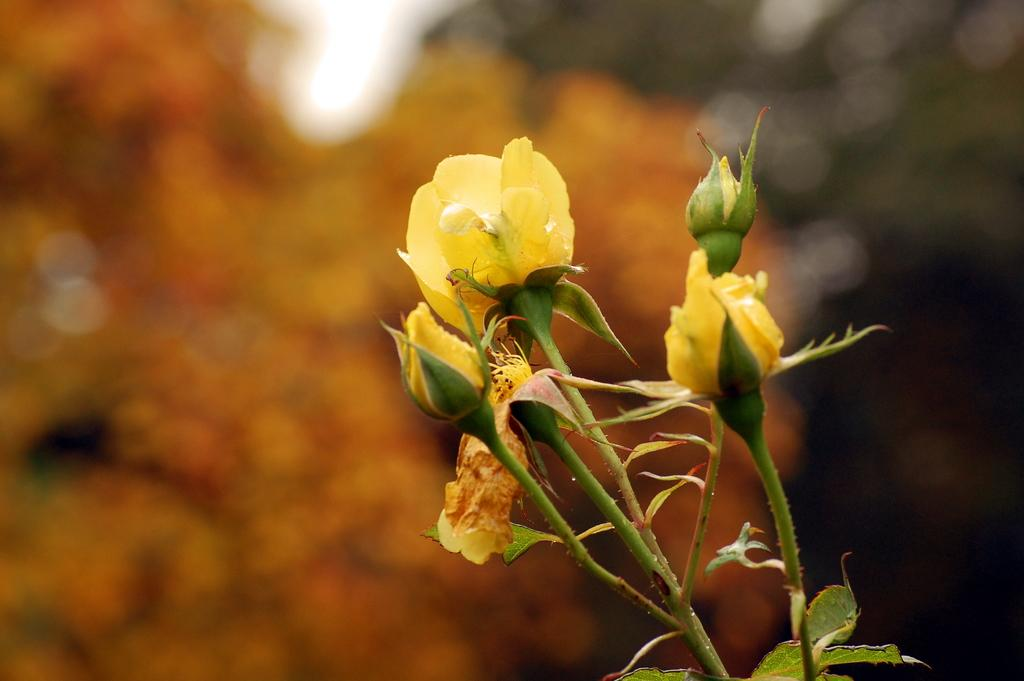What type of flower is in the image? There is a rose flower in the image. What color is the rose flower? The rose flower is yellow. Are there any unopened parts on the rose flower? Yes, there are buds on the rose flower. What else can be seen at the bottom of the image? There are leaves at the bottom of the image. How does the rose flower react to its friend in the image? There is no indication of a friend or any interaction with the rose flower in the image. 